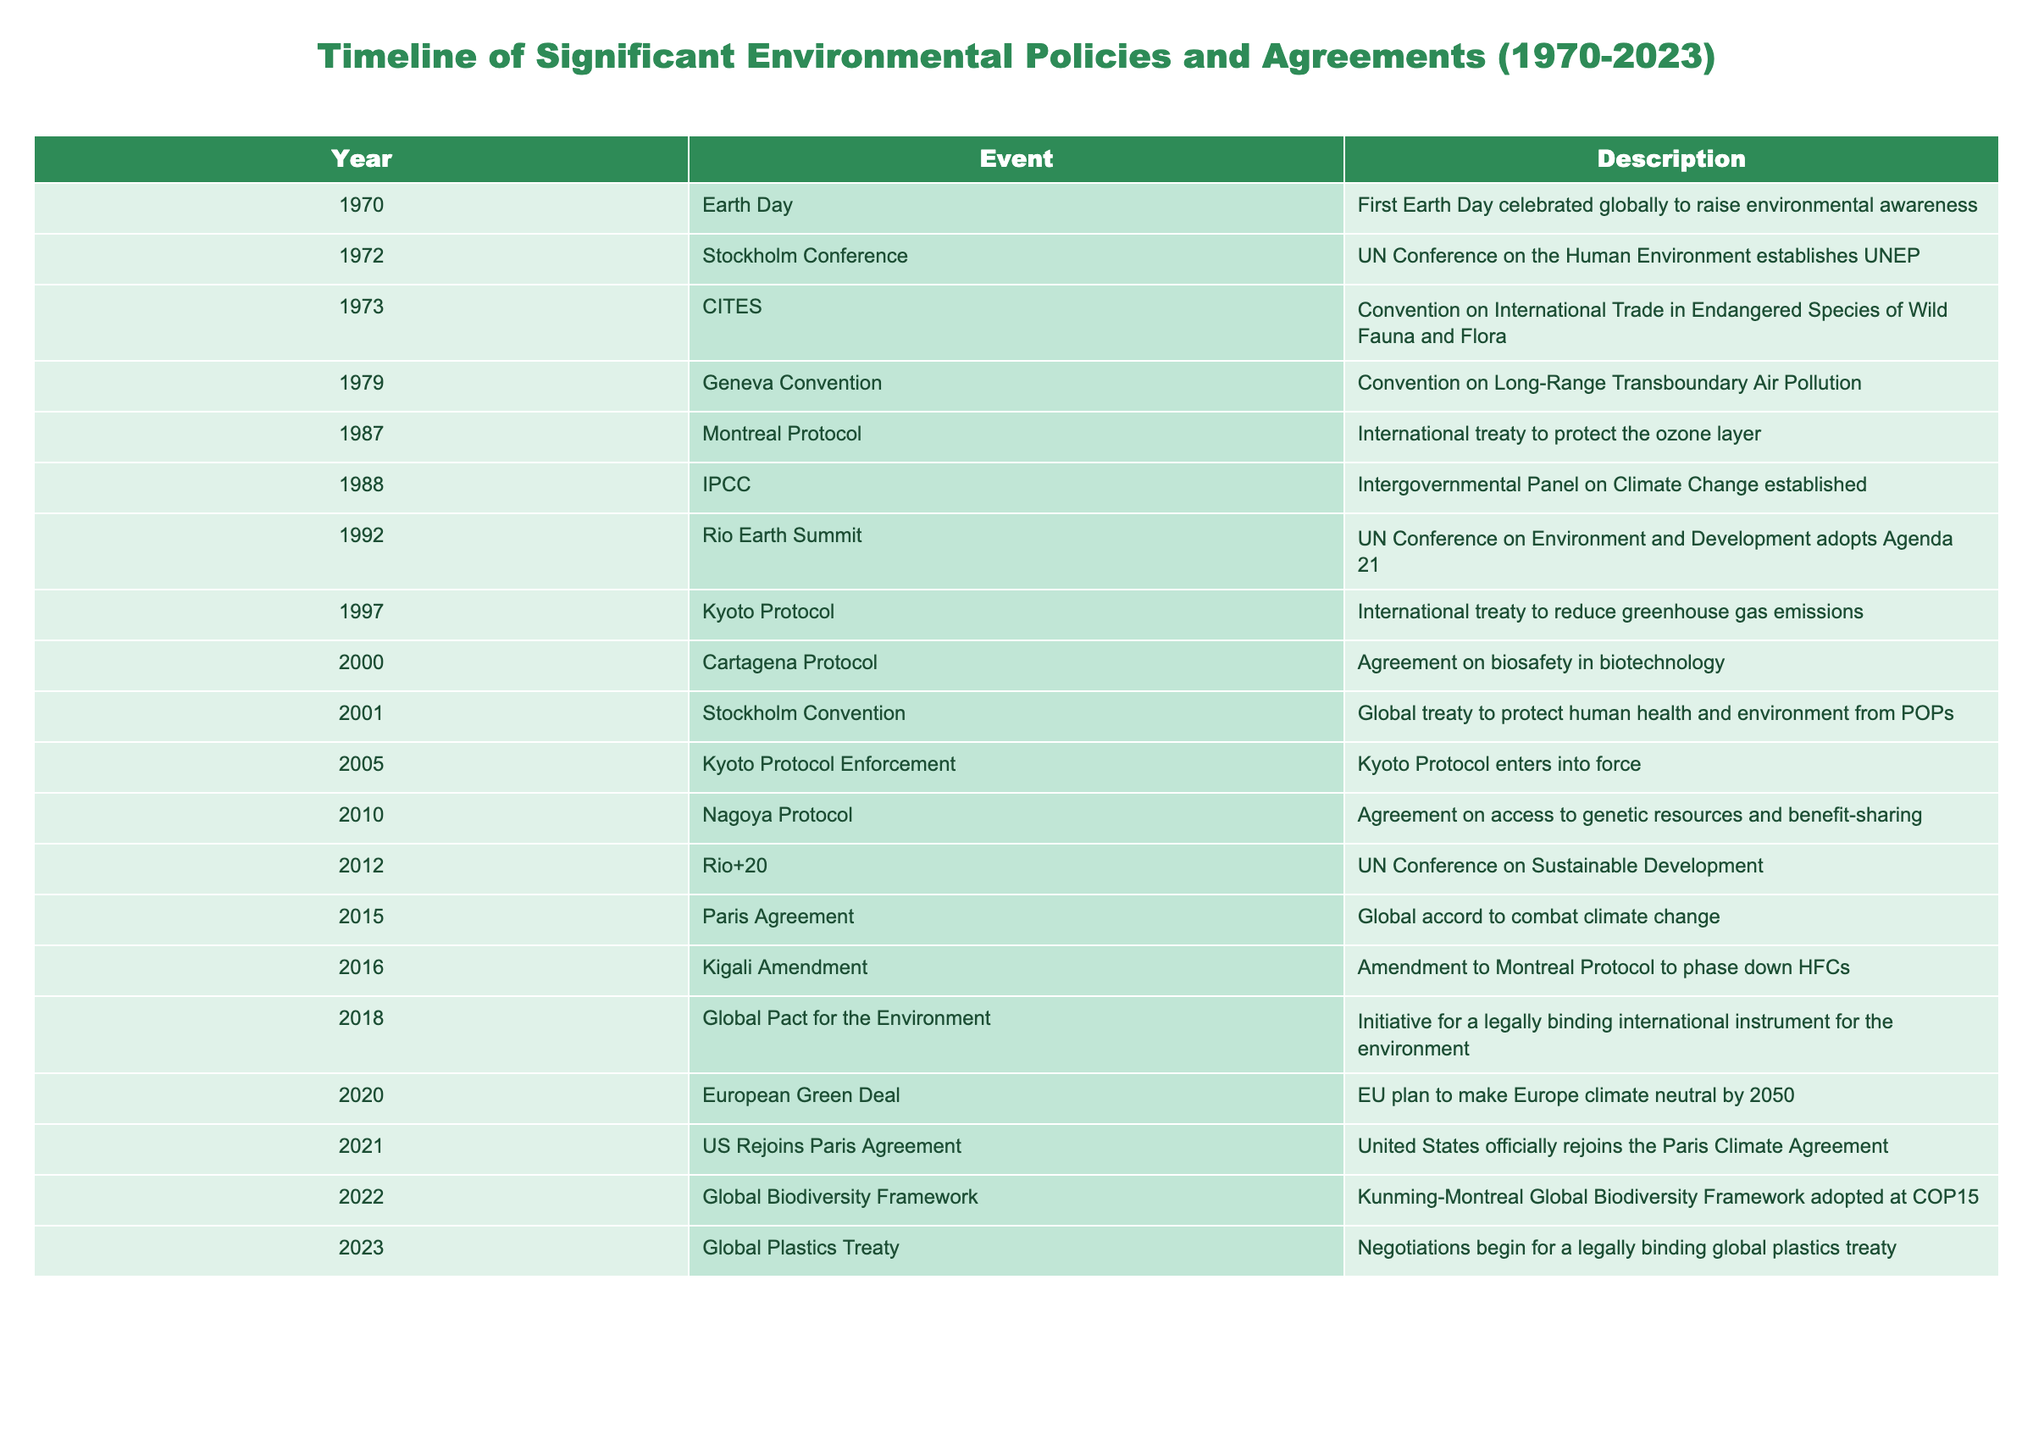What was the first event in the timeline? According to the table, the first event is "Earth Day," which took place in 1970. This is the earliest record listed under the "Year" column.
Answer: Earth Day How many years apart were the Stockholm Conference and the Montreal Protocol? The Stockholm Conference occurred in 1972, while the Montreal Protocol came about in 1987. To find the difference, subtract the earlier year from the later one: 1987 - 1972 = 15 years.
Answer: 15 years Was the Kyoto Protocol adopted before the Geneva Convention? The Kyoto Protocol was adopted in 1997, and the Geneva Convention regarding air pollution occurred in 1979. Since 1997 is later than 1979, this statement is false.
Answer: No Which event in the timeline was associated with biosafety in biotechnology? The Cartagena Protocol, which is noted in the timeline for the year 2000, is specifically related to biosafety in biotechnology as stated in its description.
Answer: Cartagena Protocol How many significant environmental agreements were established between 1992 and 2015? The table lists the following events during this period: Rio Earth Summit (1992), Kyoto Protocol (1997), Cartagena Protocol (2000), Stockholm Convention (2001), Nagoya Protocol (2010), Rio+20 (2012), and the Paris Agreement (2015). Counting these yields a total of 7 agreements.
Answer: 7 agreements Which event marked the beginning of negotiations for a global plastics treaty? According to the final entry in the table for the year 2023, the "Global Plastics Treaty" signifies the start of negotiations for a legally binding treaty on plastics.
Answer: Global Plastics Treaty How does the number of events in the 2000s compare to the 2010s? In the 2000s, there were 5 events: Cartagena Protocol (2000), Stockholm Convention (2001), Kyoto Protocol Enforcement (2005), Nagoya Protocol (2010), and Rio+20 (2012). In the 2010s, there are also 5 events: Paris Agreement (2015), Kigali Amendment (2016), Global Pact for the Environment (2018), European Green Deal (2020), and US Rejoins Paris Agreement (2021). Therefore, the number of events is equal in both decades.
Answer: They are equal Which international treaty was established to phase down HFCs? The Kigali Amendment is the specific treaty mentioned in the table for the year 2016 that aims to phase down Hydrofluorocarbons (HFCs).
Answer: Kigali Amendment What was the last significant environmental agreement listed in the table? The last agreement in the timeline, according to the year 2023 entry, is the Global Plastics Treaty, indicating a recent focus on tackling plastic pollution.
Answer: Global Plastics Treaty 